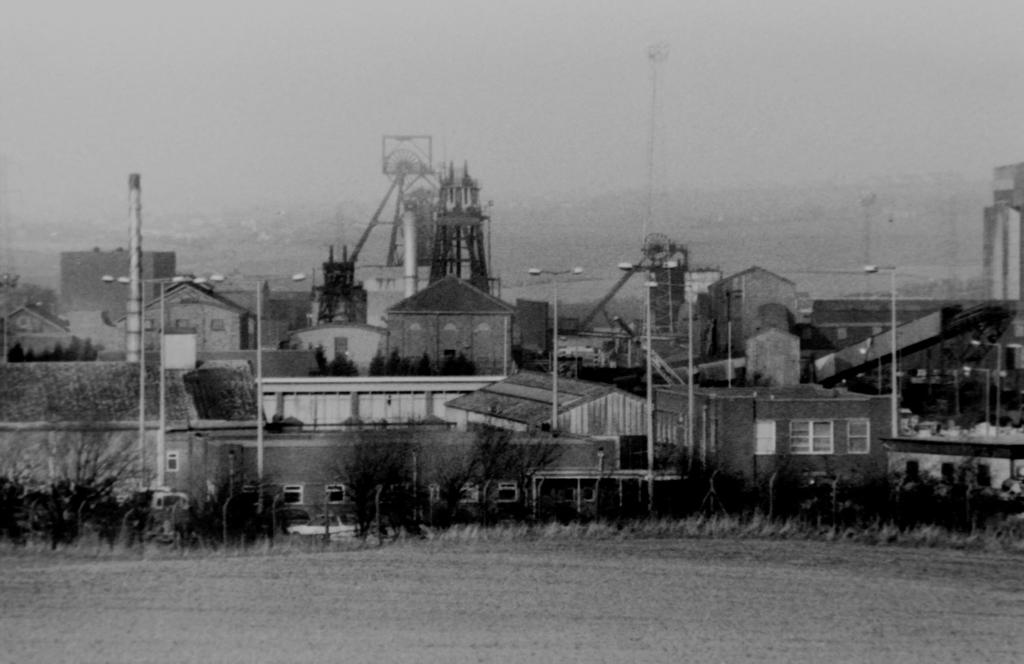What type of surface is visible in the image? There is a surface visible in the image, but the specific type is not mentioned. What can be seen growing on the surface? Trees are present on the surface in the image. What are the poles used for in the image? The purpose of the poles is not mentioned in the facts provided. What type of structures are present on the surface? Houses and buildings are present in the image. What is visible above the surface in the image? The sky is visible in the image. What type of orange is being used to tell a story in the image? There is no orange or storytelling activity present in the image. 